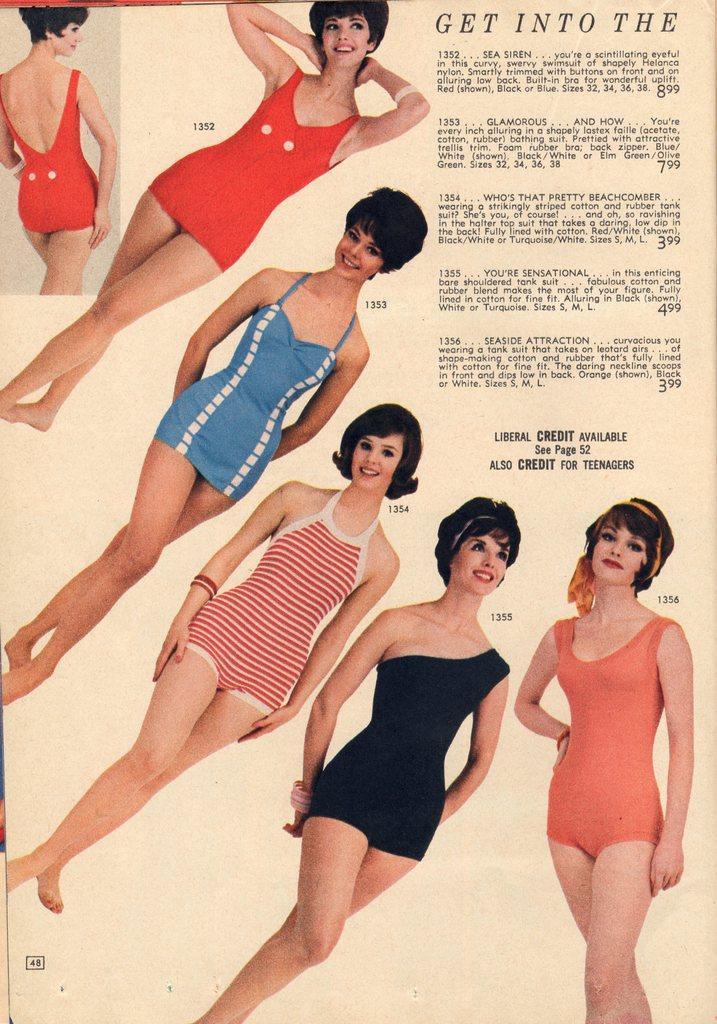In one or two sentences, can you explain what this image depicts? In this picture we can see paper on which we can see woman's picture. On the top right corner we can see paragraph. 